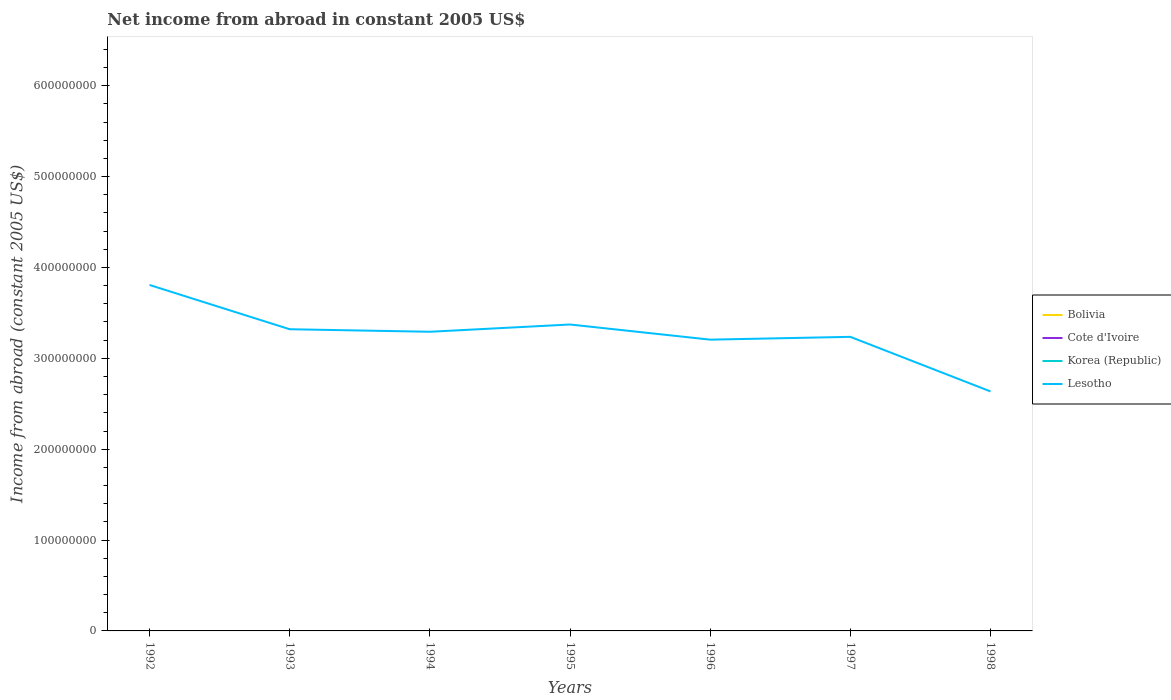Is the number of lines equal to the number of legend labels?
Offer a terse response. No. Across all years, what is the maximum net income from abroad in Lesotho?
Keep it short and to the point. 2.64e+08. What is the total net income from abroad in Lesotho in the graph?
Ensure brevity in your answer.  8.38e+06. What is the difference between the highest and the second highest net income from abroad in Lesotho?
Provide a succinct answer. 1.17e+08. How many lines are there?
Your response must be concise. 1. How many years are there in the graph?
Keep it short and to the point. 7. What is the difference between two consecutive major ticks on the Y-axis?
Make the answer very short. 1.00e+08. Where does the legend appear in the graph?
Provide a succinct answer. Center right. How are the legend labels stacked?
Provide a short and direct response. Vertical. What is the title of the graph?
Provide a short and direct response. Net income from abroad in constant 2005 US$. What is the label or title of the X-axis?
Provide a succinct answer. Years. What is the label or title of the Y-axis?
Offer a terse response. Income from abroad (constant 2005 US$). What is the Income from abroad (constant 2005 US$) in Bolivia in 1992?
Offer a very short reply. 0. What is the Income from abroad (constant 2005 US$) in Korea (Republic) in 1992?
Ensure brevity in your answer.  0. What is the Income from abroad (constant 2005 US$) of Lesotho in 1992?
Keep it short and to the point. 3.81e+08. What is the Income from abroad (constant 2005 US$) in Cote d'Ivoire in 1993?
Provide a short and direct response. 0. What is the Income from abroad (constant 2005 US$) in Korea (Republic) in 1993?
Your answer should be compact. 0. What is the Income from abroad (constant 2005 US$) in Lesotho in 1993?
Provide a succinct answer. 3.32e+08. What is the Income from abroad (constant 2005 US$) in Korea (Republic) in 1994?
Offer a terse response. 0. What is the Income from abroad (constant 2005 US$) in Lesotho in 1994?
Make the answer very short. 3.29e+08. What is the Income from abroad (constant 2005 US$) in Bolivia in 1995?
Provide a succinct answer. 0. What is the Income from abroad (constant 2005 US$) of Cote d'Ivoire in 1995?
Provide a succinct answer. 0. What is the Income from abroad (constant 2005 US$) of Korea (Republic) in 1995?
Keep it short and to the point. 0. What is the Income from abroad (constant 2005 US$) of Lesotho in 1995?
Your answer should be compact. 3.37e+08. What is the Income from abroad (constant 2005 US$) in Bolivia in 1996?
Keep it short and to the point. 0. What is the Income from abroad (constant 2005 US$) of Korea (Republic) in 1996?
Provide a short and direct response. 0. What is the Income from abroad (constant 2005 US$) in Lesotho in 1996?
Provide a succinct answer. 3.21e+08. What is the Income from abroad (constant 2005 US$) of Cote d'Ivoire in 1997?
Offer a very short reply. 0. What is the Income from abroad (constant 2005 US$) in Korea (Republic) in 1997?
Keep it short and to the point. 0. What is the Income from abroad (constant 2005 US$) of Lesotho in 1997?
Your answer should be very brief. 3.24e+08. What is the Income from abroad (constant 2005 US$) in Bolivia in 1998?
Offer a very short reply. 0. What is the Income from abroad (constant 2005 US$) of Lesotho in 1998?
Give a very brief answer. 2.64e+08. Across all years, what is the maximum Income from abroad (constant 2005 US$) in Lesotho?
Your answer should be very brief. 3.81e+08. Across all years, what is the minimum Income from abroad (constant 2005 US$) of Lesotho?
Your response must be concise. 2.64e+08. What is the total Income from abroad (constant 2005 US$) of Bolivia in the graph?
Give a very brief answer. 0. What is the total Income from abroad (constant 2005 US$) of Lesotho in the graph?
Give a very brief answer. 2.29e+09. What is the difference between the Income from abroad (constant 2005 US$) of Lesotho in 1992 and that in 1993?
Your answer should be very brief. 4.87e+07. What is the difference between the Income from abroad (constant 2005 US$) of Lesotho in 1992 and that in 1994?
Keep it short and to the point. 5.15e+07. What is the difference between the Income from abroad (constant 2005 US$) of Lesotho in 1992 and that in 1995?
Provide a succinct answer. 4.35e+07. What is the difference between the Income from abroad (constant 2005 US$) of Lesotho in 1992 and that in 1996?
Ensure brevity in your answer.  6.02e+07. What is the difference between the Income from abroad (constant 2005 US$) in Lesotho in 1992 and that in 1997?
Ensure brevity in your answer.  5.71e+07. What is the difference between the Income from abroad (constant 2005 US$) of Lesotho in 1992 and that in 1998?
Provide a succinct answer. 1.17e+08. What is the difference between the Income from abroad (constant 2005 US$) of Lesotho in 1993 and that in 1994?
Ensure brevity in your answer.  2.79e+06. What is the difference between the Income from abroad (constant 2005 US$) of Lesotho in 1993 and that in 1995?
Give a very brief answer. -5.21e+06. What is the difference between the Income from abroad (constant 2005 US$) in Lesotho in 1993 and that in 1996?
Provide a succinct answer. 1.15e+07. What is the difference between the Income from abroad (constant 2005 US$) of Lesotho in 1993 and that in 1997?
Your answer should be very brief. 8.38e+06. What is the difference between the Income from abroad (constant 2005 US$) of Lesotho in 1993 and that in 1998?
Make the answer very short. 6.84e+07. What is the difference between the Income from abroad (constant 2005 US$) of Lesotho in 1994 and that in 1995?
Provide a short and direct response. -8.00e+06. What is the difference between the Income from abroad (constant 2005 US$) of Lesotho in 1994 and that in 1996?
Make the answer very short. 8.68e+06. What is the difference between the Income from abroad (constant 2005 US$) in Lesotho in 1994 and that in 1997?
Your answer should be compact. 5.59e+06. What is the difference between the Income from abroad (constant 2005 US$) of Lesotho in 1994 and that in 1998?
Offer a very short reply. 6.56e+07. What is the difference between the Income from abroad (constant 2005 US$) in Lesotho in 1995 and that in 1996?
Provide a short and direct response. 1.67e+07. What is the difference between the Income from abroad (constant 2005 US$) in Lesotho in 1995 and that in 1997?
Offer a terse response. 1.36e+07. What is the difference between the Income from abroad (constant 2005 US$) of Lesotho in 1995 and that in 1998?
Ensure brevity in your answer.  7.36e+07. What is the difference between the Income from abroad (constant 2005 US$) of Lesotho in 1996 and that in 1997?
Offer a terse response. -3.09e+06. What is the difference between the Income from abroad (constant 2005 US$) in Lesotho in 1996 and that in 1998?
Keep it short and to the point. 5.70e+07. What is the difference between the Income from abroad (constant 2005 US$) of Lesotho in 1997 and that in 1998?
Give a very brief answer. 6.00e+07. What is the average Income from abroad (constant 2005 US$) of Cote d'Ivoire per year?
Make the answer very short. 0. What is the average Income from abroad (constant 2005 US$) in Korea (Republic) per year?
Your answer should be very brief. 0. What is the average Income from abroad (constant 2005 US$) of Lesotho per year?
Ensure brevity in your answer.  3.27e+08. What is the ratio of the Income from abroad (constant 2005 US$) in Lesotho in 1992 to that in 1993?
Make the answer very short. 1.15. What is the ratio of the Income from abroad (constant 2005 US$) in Lesotho in 1992 to that in 1994?
Offer a terse response. 1.16. What is the ratio of the Income from abroad (constant 2005 US$) in Lesotho in 1992 to that in 1995?
Provide a short and direct response. 1.13. What is the ratio of the Income from abroad (constant 2005 US$) of Lesotho in 1992 to that in 1996?
Your response must be concise. 1.19. What is the ratio of the Income from abroad (constant 2005 US$) in Lesotho in 1992 to that in 1997?
Your response must be concise. 1.18. What is the ratio of the Income from abroad (constant 2005 US$) in Lesotho in 1992 to that in 1998?
Make the answer very short. 1.44. What is the ratio of the Income from abroad (constant 2005 US$) of Lesotho in 1993 to that in 1994?
Your answer should be very brief. 1.01. What is the ratio of the Income from abroad (constant 2005 US$) in Lesotho in 1993 to that in 1995?
Provide a short and direct response. 0.98. What is the ratio of the Income from abroad (constant 2005 US$) in Lesotho in 1993 to that in 1996?
Offer a very short reply. 1.04. What is the ratio of the Income from abroad (constant 2005 US$) of Lesotho in 1993 to that in 1997?
Make the answer very short. 1.03. What is the ratio of the Income from abroad (constant 2005 US$) of Lesotho in 1993 to that in 1998?
Your answer should be compact. 1.26. What is the ratio of the Income from abroad (constant 2005 US$) in Lesotho in 1994 to that in 1995?
Keep it short and to the point. 0.98. What is the ratio of the Income from abroad (constant 2005 US$) in Lesotho in 1994 to that in 1996?
Your response must be concise. 1.03. What is the ratio of the Income from abroad (constant 2005 US$) of Lesotho in 1994 to that in 1997?
Give a very brief answer. 1.02. What is the ratio of the Income from abroad (constant 2005 US$) in Lesotho in 1994 to that in 1998?
Offer a terse response. 1.25. What is the ratio of the Income from abroad (constant 2005 US$) of Lesotho in 1995 to that in 1996?
Your response must be concise. 1.05. What is the ratio of the Income from abroad (constant 2005 US$) of Lesotho in 1995 to that in 1997?
Provide a succinct answer. 1.04. What is the ratio of the Income from abroad (constant 2005 US$) of Lesotho in 1995 to that in 1998?
Your response must be concise. 1.28. What is the ratio of the Income from abroad (constant 2005 US$) in Lesotho in 1996 to that in 1998?
Give a very brief answer. 1.22. What is the ratio of the Income from abroad (constant 2005 US$) of Lesotho in 1997 to that in 1998?
Provide a succinct answer. 1.23. What is the difference between the highest and the second highest Income from abroad (constant 2005 US$) in Lesotho?
Offer a very short reply. 4.35e+07. What is the difference between the highest and the lowest Income from abroad (constant 2005 US$) in Lesotho?
Offer a terse response. 1.17e+08. 